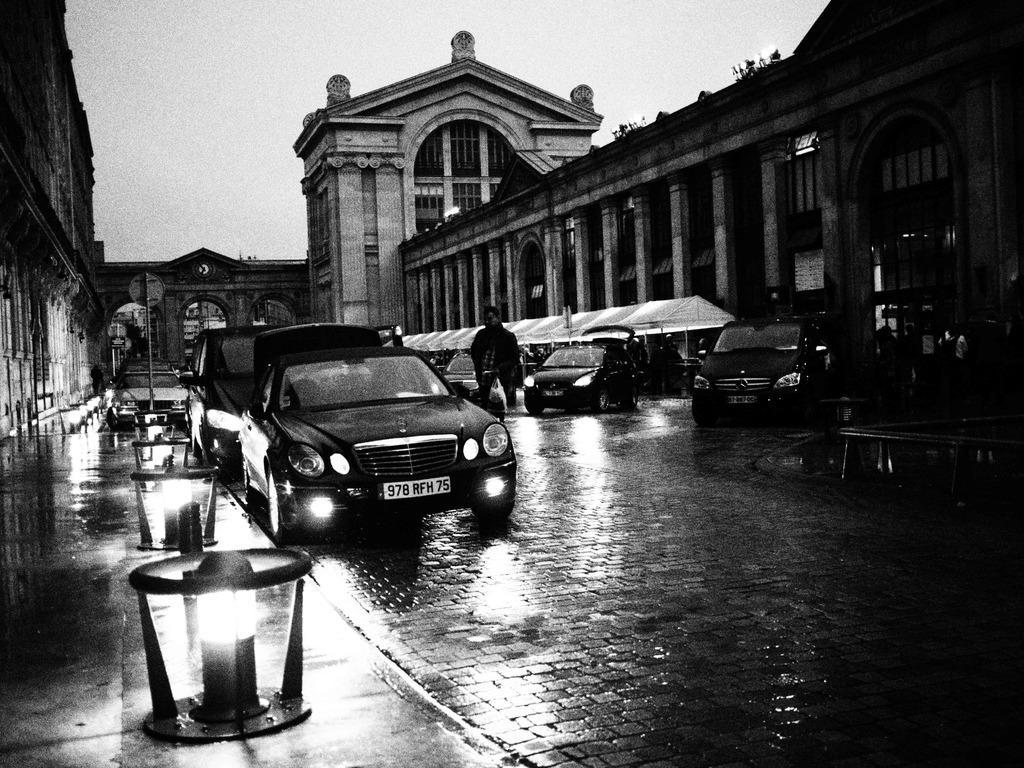How would you summarize this image in a sentence or two? In this picture we can see vehicles on the road, person, lights, tents, buildings and some objects and in the background we can see the sky. 